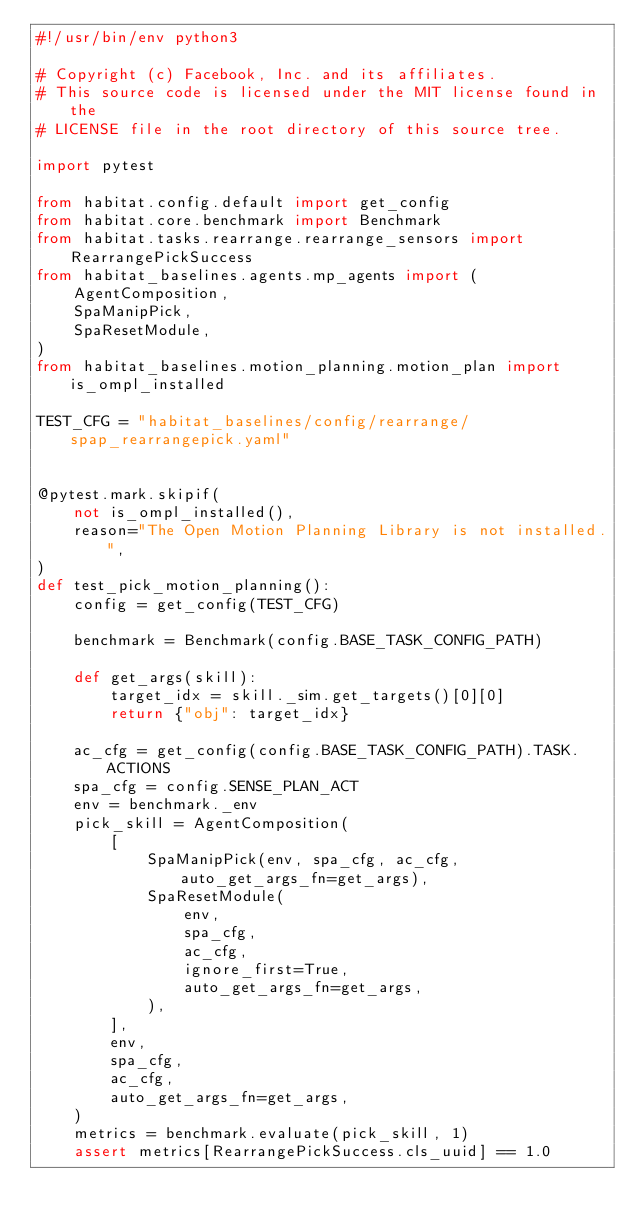Convert code to text. <code><loc_0><loc_0><loc_500><loc_500><_Python_>#!/usr/bin/env python3

# Copyright (c) Facebook, Inc. and its affiliates.
# This source code is licensed under the MIT license found in the
# LICENSE file in the root directory of this source tree.

import pytest

from habitat.config.default import get_config
from habitat.core.benchmark import Benchmark
from habitat.tasks.rearrange.rearrange_sensors import RearrangePickSuccess
from habitat_baselines.agents.mp_agents import (
    AgentComposition,
    SpaManipPick,
    SpaResetModule,
)
from habitat_baselines.motion_planning.motion_plan import is_ompl_installed

TEST_CFG = "habitat_baselines/config/rearrange/spap_rearrangepick.yaml"


@pytest.mark.skipif(
    not is_ompl_installed(),
    reason="The Open Motion Planning Library is not installed.",
)
def test_pick_motion_planning():
    config = get_config(TEST_CFG)

    benchmark = Benchmark(config.BASE_TASK_CONFIG_PATH)

    def get_args(skill):
        target_idx = skill._sim.get_targets()[0][0]
        return {"obj": target_idx}

    ac_cfg = get_config(config.BASE_TASK_CONFIG_PATH).TASK.ACTIONS
    spa_cfg = config.SENSE_PLAN_ACT
    env = benchmark._env
    pick_skill = AgentComposition(
        [
            SpaManipPick(env, spa_cfg, ac_cfg, auto_get_args_fn=get_args),
            SpaResetModule(
                env,
                spa_cfg,
                ac_cfg,
                ignore_first=True,
                auto_get_args_fn=get_args,
            ),
        ],
        env,
        spa_cfg,
        ac_cfg,
        auto_get_args_fn=get_args,
    )
    metrics = benchmark.evaluate(pick_skill, 1)
    assert metrics[RearrangePickSuccess.cls_uuid] == 1.0
</code> 